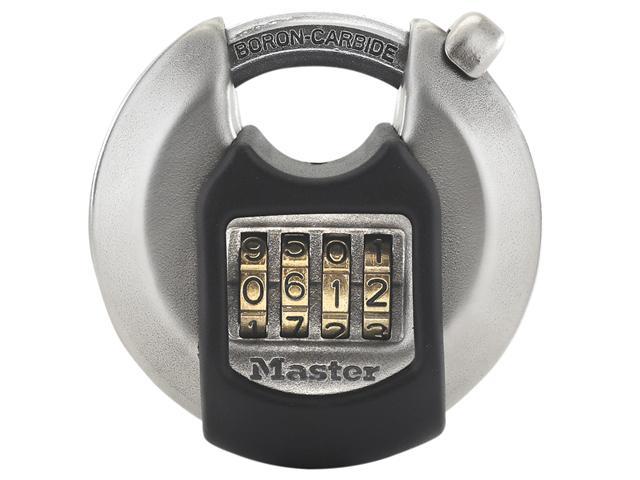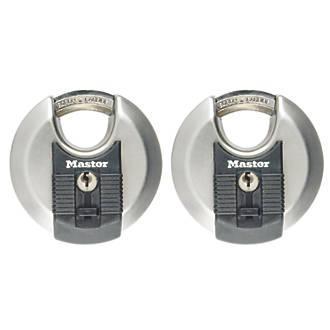The first image is the image on the left, the second image is the image on the right. Considering the images on both sides, is "All of the locks require keys." valid? Answer yes or no. No. The first image is the image on the left, the second image is the image on the right. Given the left and right images, does the statement "Each image shows one non-square lock, and neither lock has wheels with a combination on the front." hold true? Answer yes or no. No. 